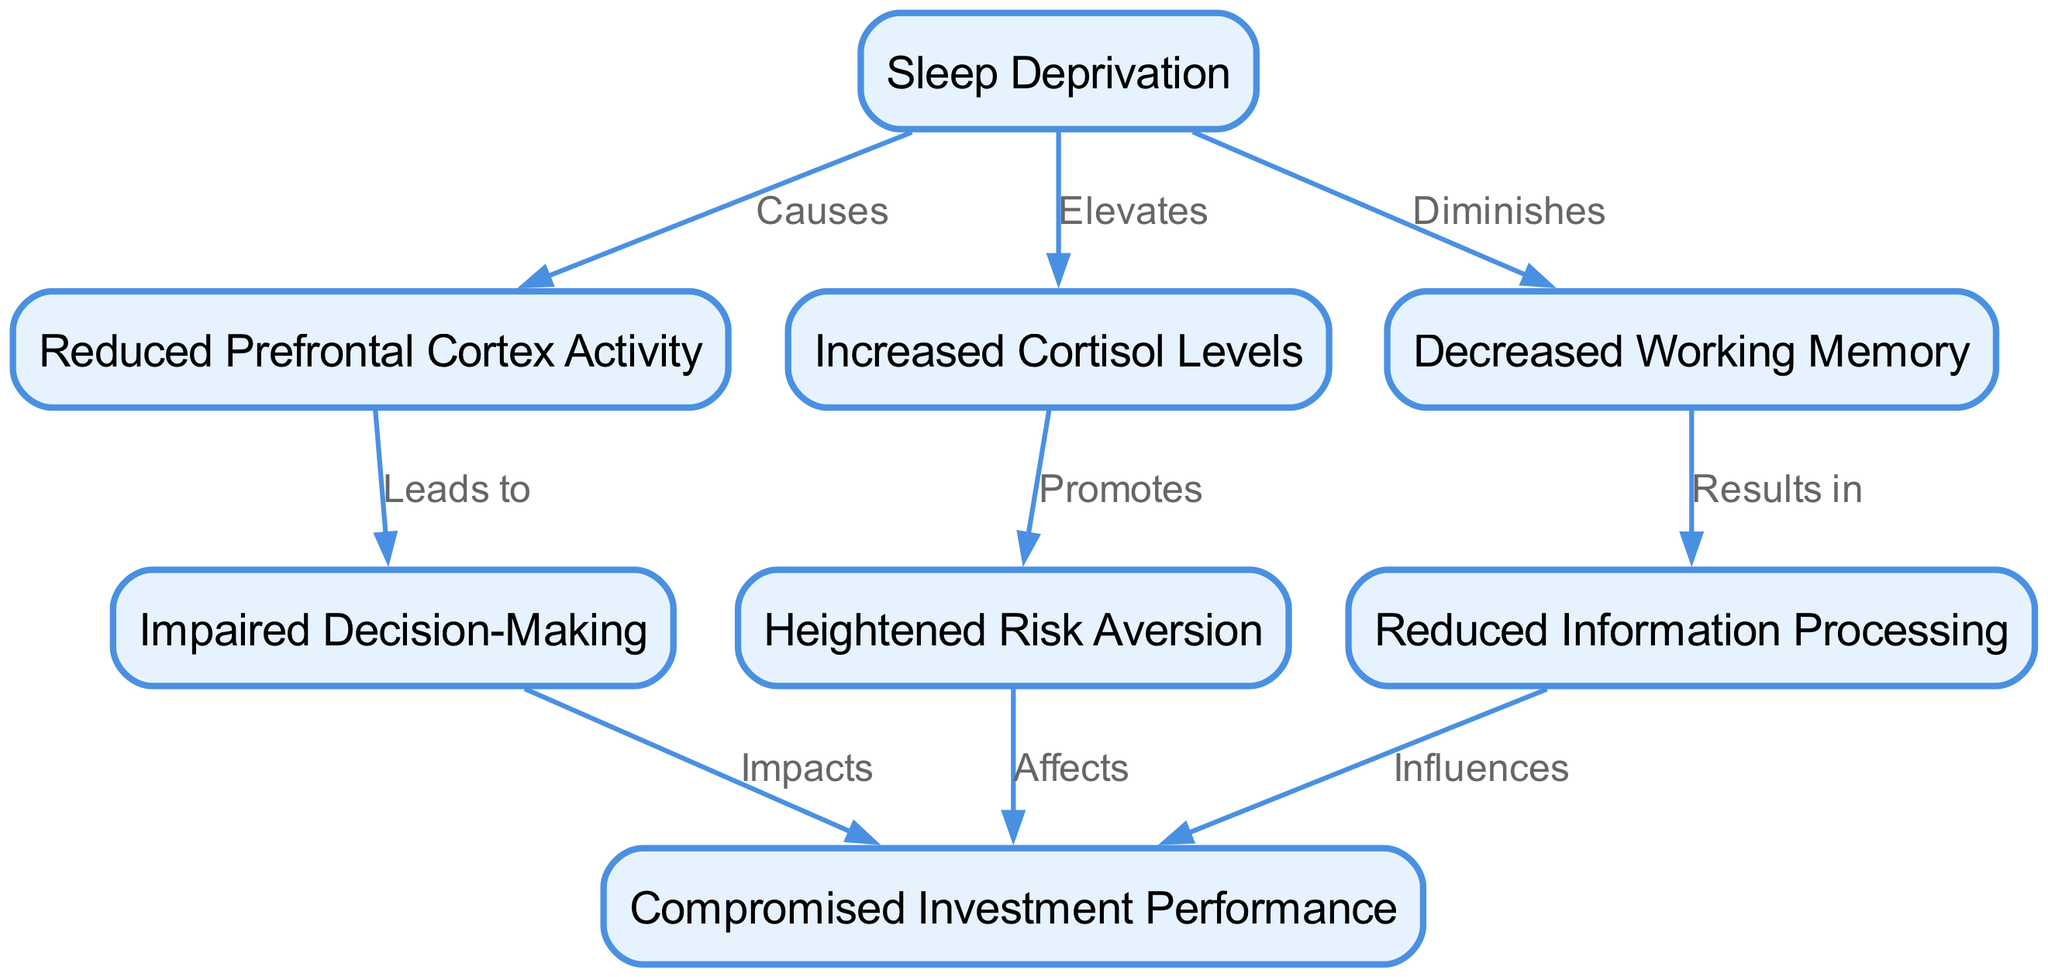What is the first node in the diagram? The first node listed is "Sleep Deprivation," which is the starting point for the physiological effects depicted.
Answer: Sleep Deprivation How many edges are there in total? To determine the total number of edges, we count all connections from one node to another. There are 8 edges shown in the diagram.
Answer: 8 What does "Sleep Deprivation" cause? According to the diagram, "Sleep Deprivation" causes "Reduced Prefrontal Cortex Activity," "Increased Cortisol Levels," and "Decreased Working Memory."
Answer: Reduced Prefrontal Cortex Activity, Increased Cortisol Levels, Decreased Working Memory Which node is impacted by both "Impaired Decision-Making" and "Heightened Risk Aversion"? The node "Compromised Investment Performance" is impacted by both "Impaired Decision-Making" and "Heightened Risk Aversion" as indicated by directed edges leading into it.
Answer: Compromised Investment Performance What leads to "Impaired Decision-Making"? The diagram shows that "Reduced Prefrontal Cortex Activity" leads to "Impaired Decision-Making." Therefore, the direct precursor is "Reduced Prefrontal Cortex Activity."
Answer: Reduced Prefrontal Cortex Activity How does "Increased Cortisol Levels" affect investment performance? The edge from "Increased Cortisol Levels" to "Heightened Risk Aversion" indicates that it promotes heightened risk aversion, which in turn affects "Compromised Investment Performance."
Answer: Affects Which physiological effect results in reduced working memory? The diagram states that "Decreased Working Memory" results from "Reduced Prefrontal Cortex Activity." Therefore, this physiological effect is tied to reduced prefrontal cortex functioning.
Answer: Reduced Prefrontal Cortex Activity What is the relationship between "Increased Cortisol Levels" and "Heightened Risk Aversion"? The diagram specifies that "Increased Cortisol Levels" promotes "Heightened Risk Aversion," which shows a direct causal relationship between the two nodes.
Answer: Promotes Which node has multiple influences leading to "Compromised Investment Performance"? The node "Compromised Investment Performance" has influences from "Impaired Decision-Making," "Heightened Risk Aversion," and "Reduced Information Processing," illustrating that multiple factors contribute to its outcome.
Answer: Compromised Investment Performance 